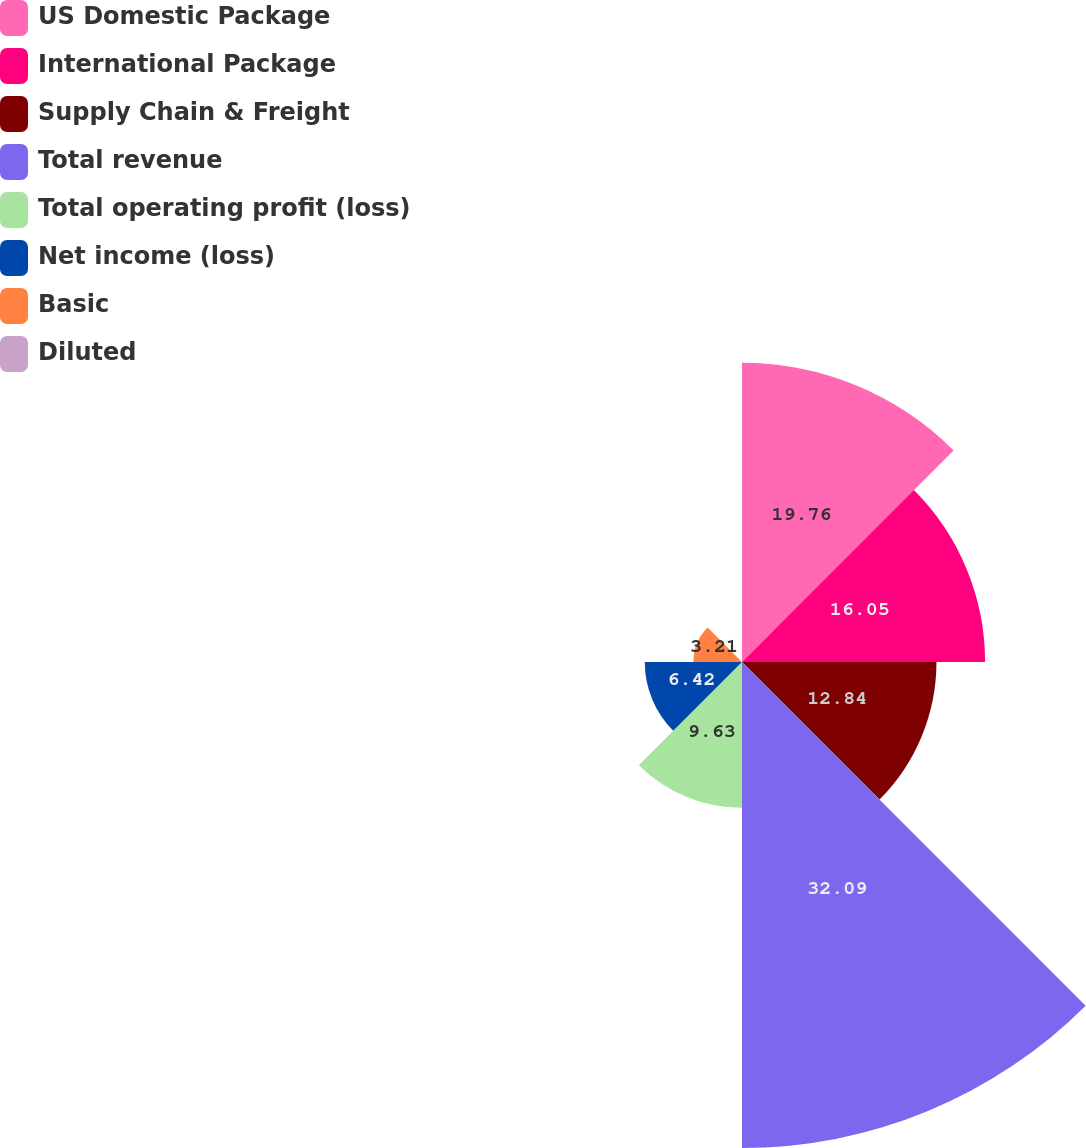Convert chart. <chart><loc_0><loc_0><loc_500><loc_500><pie_chart><fcel>US Domestic Package<fcel>International Package<fcel>Supply Chain & Freight<fcel>Total revenue<fcel>Total operating profit (loss)<fcel>Net income (loss)<fcel>Basic<fcel>Diluted<nl><fcel>19.76%<fcel>16.05%<fcel>12.84%<fcel>32.09%<fcel>9.63%<fcel>6.42%<fcel>3.21%<fcel>0.0%<nl></chart> 